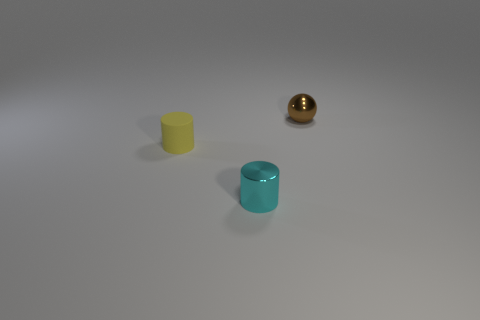Describe the objects in the image and their arrangement. In the image, there are three distinctly colored cylindrical objects lying on a flat surface, arranged in a roughly diagonal line from the bottom-left to the upper-right of the frame. Starting from the bottom-left, there's a yellow cylinder, followed by a turquoise one, and lastly, a shiny brown sphere that you might describe as bronze or perhaps gold in color. 